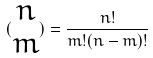Convert formula to latex. <formula><loc_0><loc_0><loc_500><loc_500>( \begin{matrix} n \\ m \end{matrix} ) = \frac { n ! } { m ! ( n - m ) ! }</formula> 